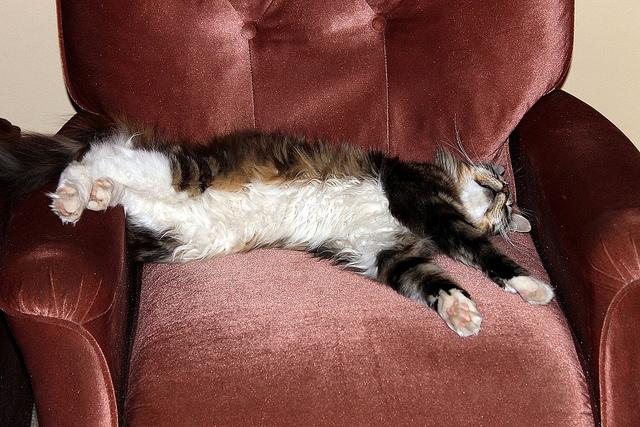What is the cat doing?
Be succinct. Sleeping. What color is the cat's belly?
Answer briefly. White. Does the cat look comfortable?
Keep it brief. Yes. 